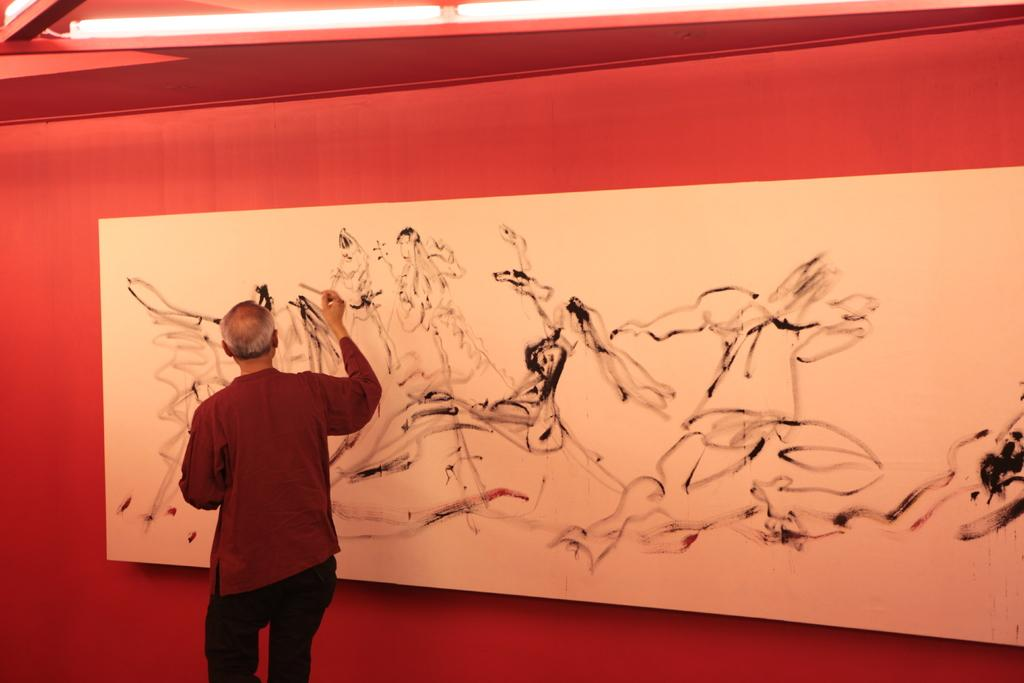Who or what is the main subject in the image? There is a person in the image. What is the person wearing? The person is wearing a dress. What is in front of the person? There is a board in front of the person. What is on the board? There is a painting on the board. What colors are predominant in the background of the image? The background of the image is red and white. What type of clover can be seen growing in the background of the image? There is no clover visible in the image; the background is red and white. How does the person in the image prepare for winter? The image does not provide any information about the person preparing for winter. 